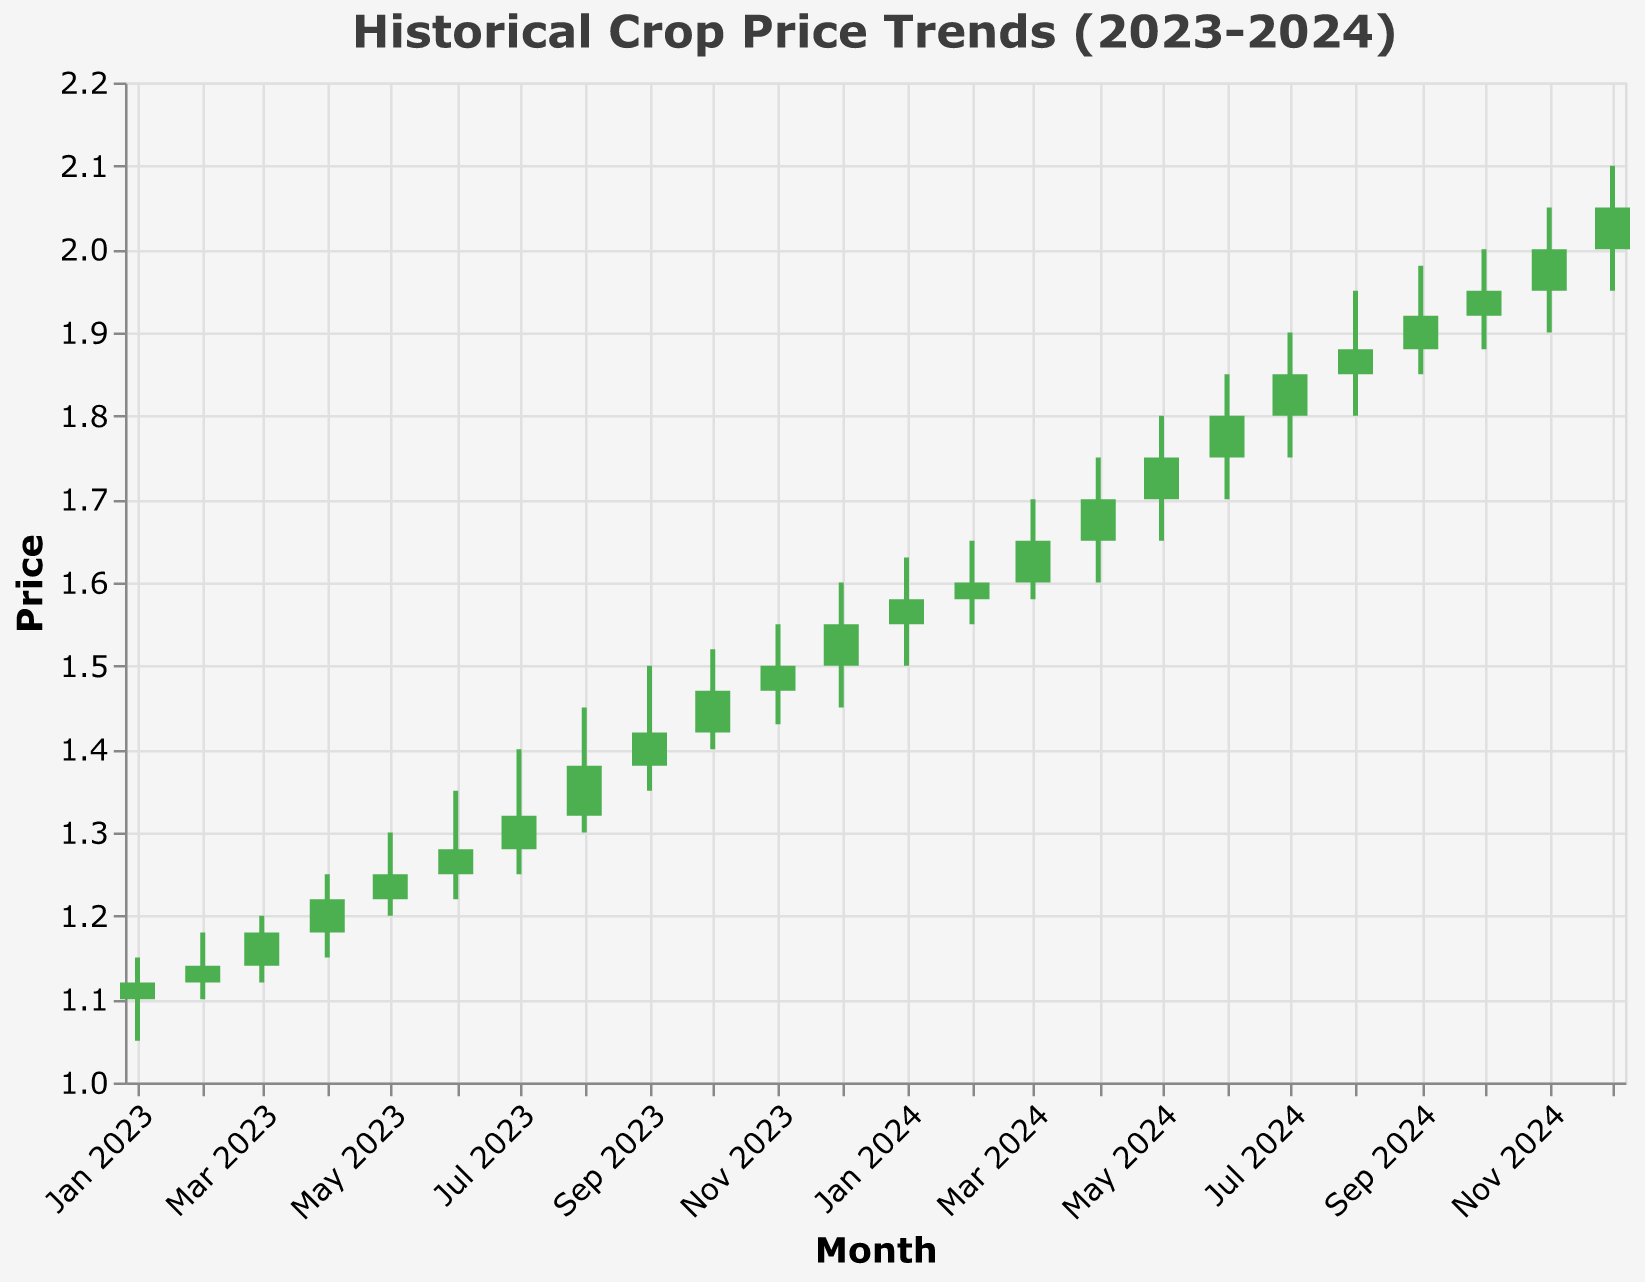What is the title of the plot? The title is usually displayed at the top of the plot and is written in plain text to give viewers a quick understanding of the overall topic. Here, it is "Historical Crop Price Trends (2023-2024)."
Answer: Historical Crop Price Trends (2023-2024) What is the highest closing price observed in 2024? To find the highest closing price in 2024, check the last column (Close) for the last 12 data points (2024). The highest value is observed on the date "2024-12-01" with a closing price of 2.05.
Answer: 2.05 What is the initial opening price in 2023? To determine the initial opening price in 2023, look at the first row under the "Open" column. The initial opening price was on "2023-01-01" with a value of 1.10.
Answer: 1.10 In which month did the price show the largest increase from its opening to closing price? Calculate the difference between the close and open prices for each month. The largest increase is observed in "2023-03-01" with a difference of 0.04 (1.18 - 1.14).
Answer: March 2023 During which month in 2023 did the price close lower than its opening price? Review the months in 2023 where the closing price is lower than the opening price. On "2023-11-01," the opening price was 1.47, and the closing price was 1.50, which shows the price actually increased, hence none in 2023.
Answer: None Which month had the highest volatility in 2023? Volatility can be measured by the range (High - Low). Check the values for 2023. The highest volatility month is "2023-08-01" with a range of 0.15 (1.45 - 1.30).
Answer: August 2023 Compare the closing prices of April 2023 and April 2024. Which one is higher? Compare the closing price for "2023-04-01" which is 1.22, and "2024-04-01," which is 1.70. The closing price in April 2024 is higher.
Answer: April 2024 How many times did the stock have a higher closing price than the opening price in 2023? Count the months in 2023 where the closing price is higher than the opening price. The months are March, April, May, June, July, August, September, October, December. That's 9 times.
Answer: 9 times Across the two years (2023 and 2024), during which month did the price reach the peak value? To find this, look at the maximum of the "High" column for all months. The highest value is observed in December 2024 with a high of 2.10.
Answer: December 2024 What is the average closing price in 2023? To find the average closing price, sum all the closing prices in 2023 and divide by the number of months. The sum is (1.12 + 1.14 + 1.18 + 1.22 + 1.25 + 1.28 + 1.32 + 1.38 + 1.42 + 1.47 + 1.50 + 1.55) = 15.83. There are 12 months, so the average is 15.83/12 = 1.32.
Answer: 1.32 